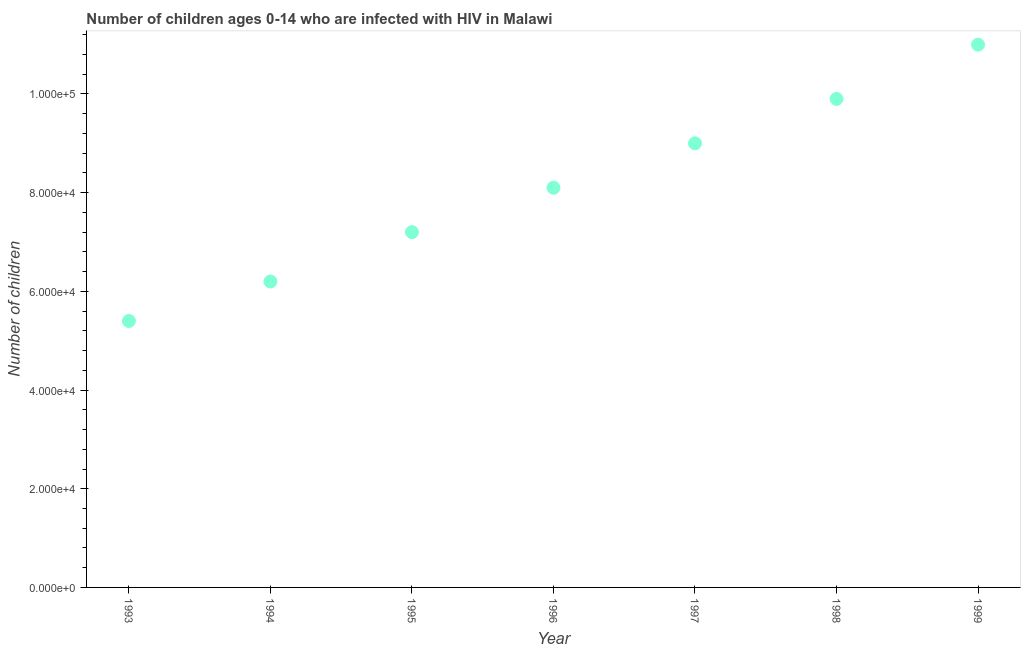What is the number of children living with hiv in 1999?
Your response must be concise. 1.10e+05. Across all years, what is the maximum number of children living with hiv?
Offer a terse response. 1.10e+05. Across all years, what is the minimum number of children living with hiv?
Keep it short and to the point. 5.40e+04. What is the sum of the number of children living with hiv?
Offer a very short reply. 5.68e+05. What is the difference between the number of children living with hiv in 1996 and 1997?
Make the answer very short. -9000. What is the average number of children living with hiv per year?
Offer a terse response. 8.11e+04. What is the median number of children living with hiv?
Offer a terse response. 8.10e+04. What is the ratio of the number of children living with hiv in 1995 to that in 1996?
Your answer should be compact. 0.89. What is the difference between the highest and the second highest number of children living with hiv?
Your answer should be very brief. 1.10e+04. Is the sum of the number of children living with hiv in 1995 and 1999 greater than the maximum number of children living with hiv across all years?
Your answer should be compact. Yes. What is the difference between the highest and the lowest number of children living with hiv?
Offer a very short reply. 5.60e+04. Does the number of children living with hiv monotonically increase over the years?
Provide a short and direct response. Yes. Are the values on the major ticks of Y-axis written in scientific E-notation?
Your answer should be very brief. Yes. Does the graph contain any zero values?
Make the answer very short. No. What is the title of the graph?
Your answer should be compact. Number of children ages 0-14 who are infected with HIV in Malawi. What is the label or title of the Y-axis?
Your response must be concise. Number of children. What is the Number of children in 1993?
Make the answer very short. 5.40e+04. What is the Number of children in 1994?
Offer a very short reply. 6.20e+04. What is the Number of children in 1995?
Offer a terse response. 7.20e+04. What is the Number of children in 1996?
Your response must be concise. 8.10e+04. What is the Number of children in 1998?
Your answer should be compact. 9.90e+04. What is the Number of children in 1999?
Make the answer very short. 1.10e+05. What is the difference between the Number of children in 1993 and 1994?
Your answer should be compact. -8000. What is the difference between the Number of children in 1993 and 1995?
Offer a terse response. -1.80e+04. What is the difference between the Number of children in 1993 and 1996?
Your answer should be compact. -2.70e+04. What is the difference between the Number of children in 1993 and 1997?
Offer a terse response. -3.60e+04. What is the difference between the Number of children in 1993 and 1998?
Provide a succinct answer. -4.50e+04. What is the difference between the Number of children in 1993 and 1999?
Offer a very short reply. -5.60e+04. What is the difference between the Number of children in 1994 and 1996?
Keep it short and to the point. -1.90e+04. What is the difference between the Number of children in 1994 and 1997?
Your answer should be very brief. -2.80e+04. What is the difference between the Number of children in 1994 and 1998?
Offer a very short reply. -3.70e+04. What is the difference between the Number of children in 1994 and 1999?
Your answer should be very brief. -4.80e+04. What is the difference between the Number of children in 1995 and 1996?
Your answer should be compact. -9000. What is the difference between the Number of children in 1995 and 1997?
Provide a succinct answer. -1.80e+04. What is the difference between the Number of children in 1995 and 1998?
Your answer should be compact. -2.70e+04. What is the difference between the Number of children in 1995 and 1999?
Keep it short and to the point. -3.80e+04. What is the difference between the Number of children in 1996 and 1997?
Provide a short and direct response. -9000. What is the difference between the Number of children in 1996 and 1998?
Provide a succinct answer. -1.80e+04. What is the difference between the Number of children in 1996 and 1999?
Provide a short and direct response. -2.90e+04. What is the difference between the Number of children in 1997 and 1998?
Make the answer very short. -9000. What is the difference between the Number of children in 1998 and 1999?
Offer a very short reply. -1.10e+04. What is the ratio of the Number of children in 1993 to that in 1994?
Your answer should be compact. 0.87. What is the ratio of the Number of children in 1993 to that in 1996?
Offer a very short reply. 0.67. What is the ratio of the Number of children in 1993 to that in 1998?
Your answer should be compact. 0.55. What is the ratio of the Number of children in 1993 to that in 1999?
Your response must be concise. 0.49. What is the ratio of the Number of children in 1994 to that in 1995?
Your answer should be very brief. 0.86. What is the ratio of the Number of children in 1994 to that in 1996?
Keep it short and to the point. 0.77. What is the ratio of the Number of children in 1994 to that in 1997?
Make the answer very short. 0.69. What is the ratio of the Number of children in 1994 to that in 1998?
Ensure brevity in your answer.  0.63. What is the ratio of the Number of children in 1994 to that in 1999?
Provide a succinct answer. 0.56. What is the ratio of the Number of children in 1995 to that in 1996?
Offer a very short reply. 0.89. What is the ratio of the Number of children in 1995 to that in 1998?
Your response must be concise. 0.73. What is the ratio of the Number of children in 1995 to that in 1999?
Offer a very short reply. 0.66. What is the ratio of the Number of children in 1996 to that in 1997?
Provide a succinct answer. 0.9. What is the ratio of the Number of children in 1996 to that in 1998?
Your answer should be very brief. 0.82. What is the ratio of the Number of children in 1996 to that in 1999?
Make the answer very short. 0.74. What is the ratio of the Number of children in 1997 to that in 1998?
Give a very brief answer. 0.91. What is the ratio of the Number of children in 1997 to that in 1999?
Provide a succinct answer. 0.82. 